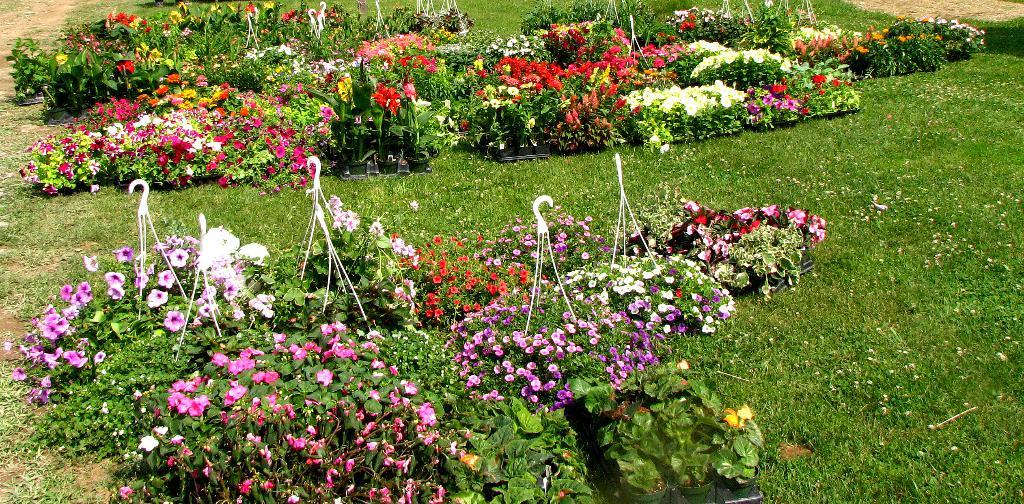What type of vegetation can be seen in the image? There are plants and flowers in the image. What type of ground cover is present in the image? There is grass in the image. What type of toys can be seen in the image? There are no toys present in the image; it features plants, flowers, and grass. What part of the house is visible in the image? There is no part of a house, such as a roof, visible in the image; it focuses on vegetation. 